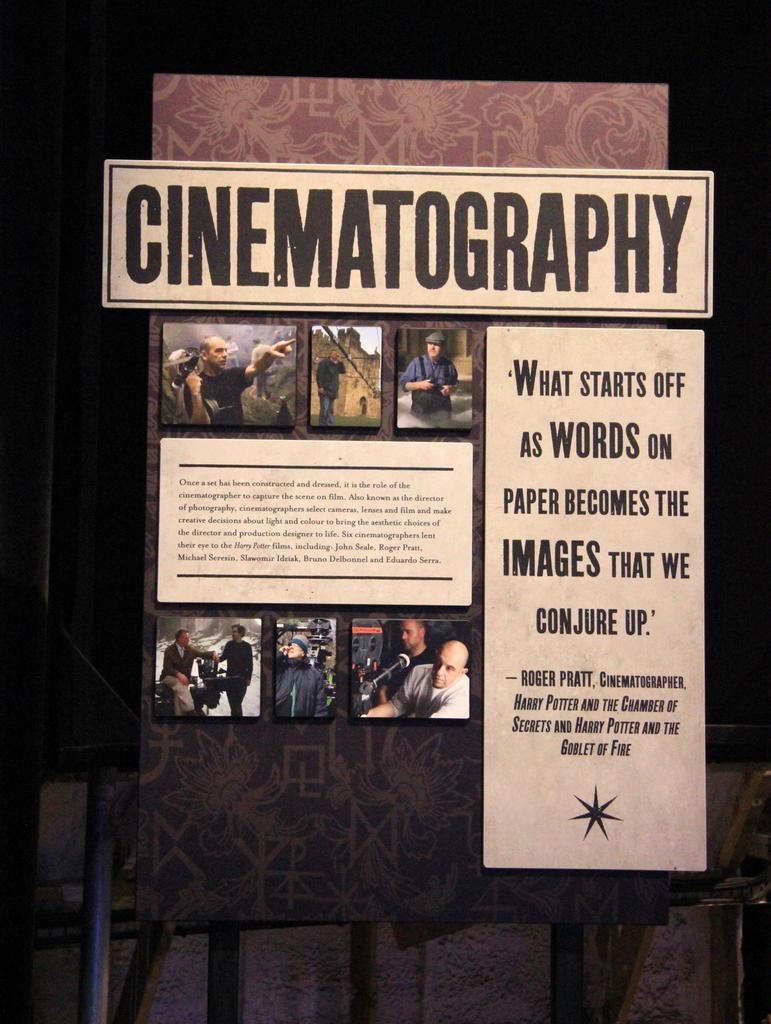<image>
Provide a brief description of the given image. a book that was made for cinematography and has directors on it 